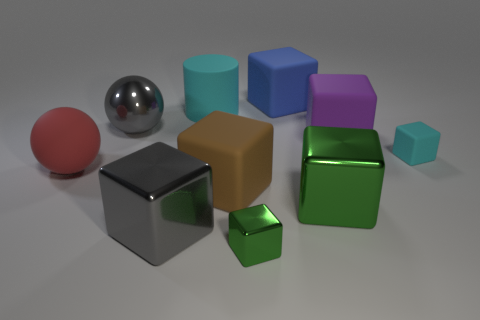Is there any other thing that has the same color as the cylinder?
Provide a succinct answer. Yes. Is the color of the small object on the left side of the cyan cube the same as the metallic thing on the right side of the blue rubber block?
Offer a very short reply. Yes. Are there any metallic things?
Provide a succinct answer. Yes. Are there any spheres made of the same material as the large green cube?
Your answer should be very brief. Yes. What is the color of the small shiny thing?
Your answer should be compact. Green. The small rubber object that is the same color as the cylinder is what shape?
Make the answer very short. Cube. What is the color of the matte sphere that is the same size as the cylinder?
Your answer should be very brief. Red. How many matte things are large cylinders or red balls?
Give a very brief answer. 2. What number of cubes are both in front of the brown block and right of the tiny green block?
Provide a short and direct response. 1. Is there any other thing that is the same shape as the small rubber object?
Your response must be concise. Yes. 